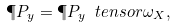<formula> <loc_0><loc_0><loc_500><loc_500>\P P _ { y } = \P P _ { y } \ t e n s o r \omega _ { X } ,</formula> 